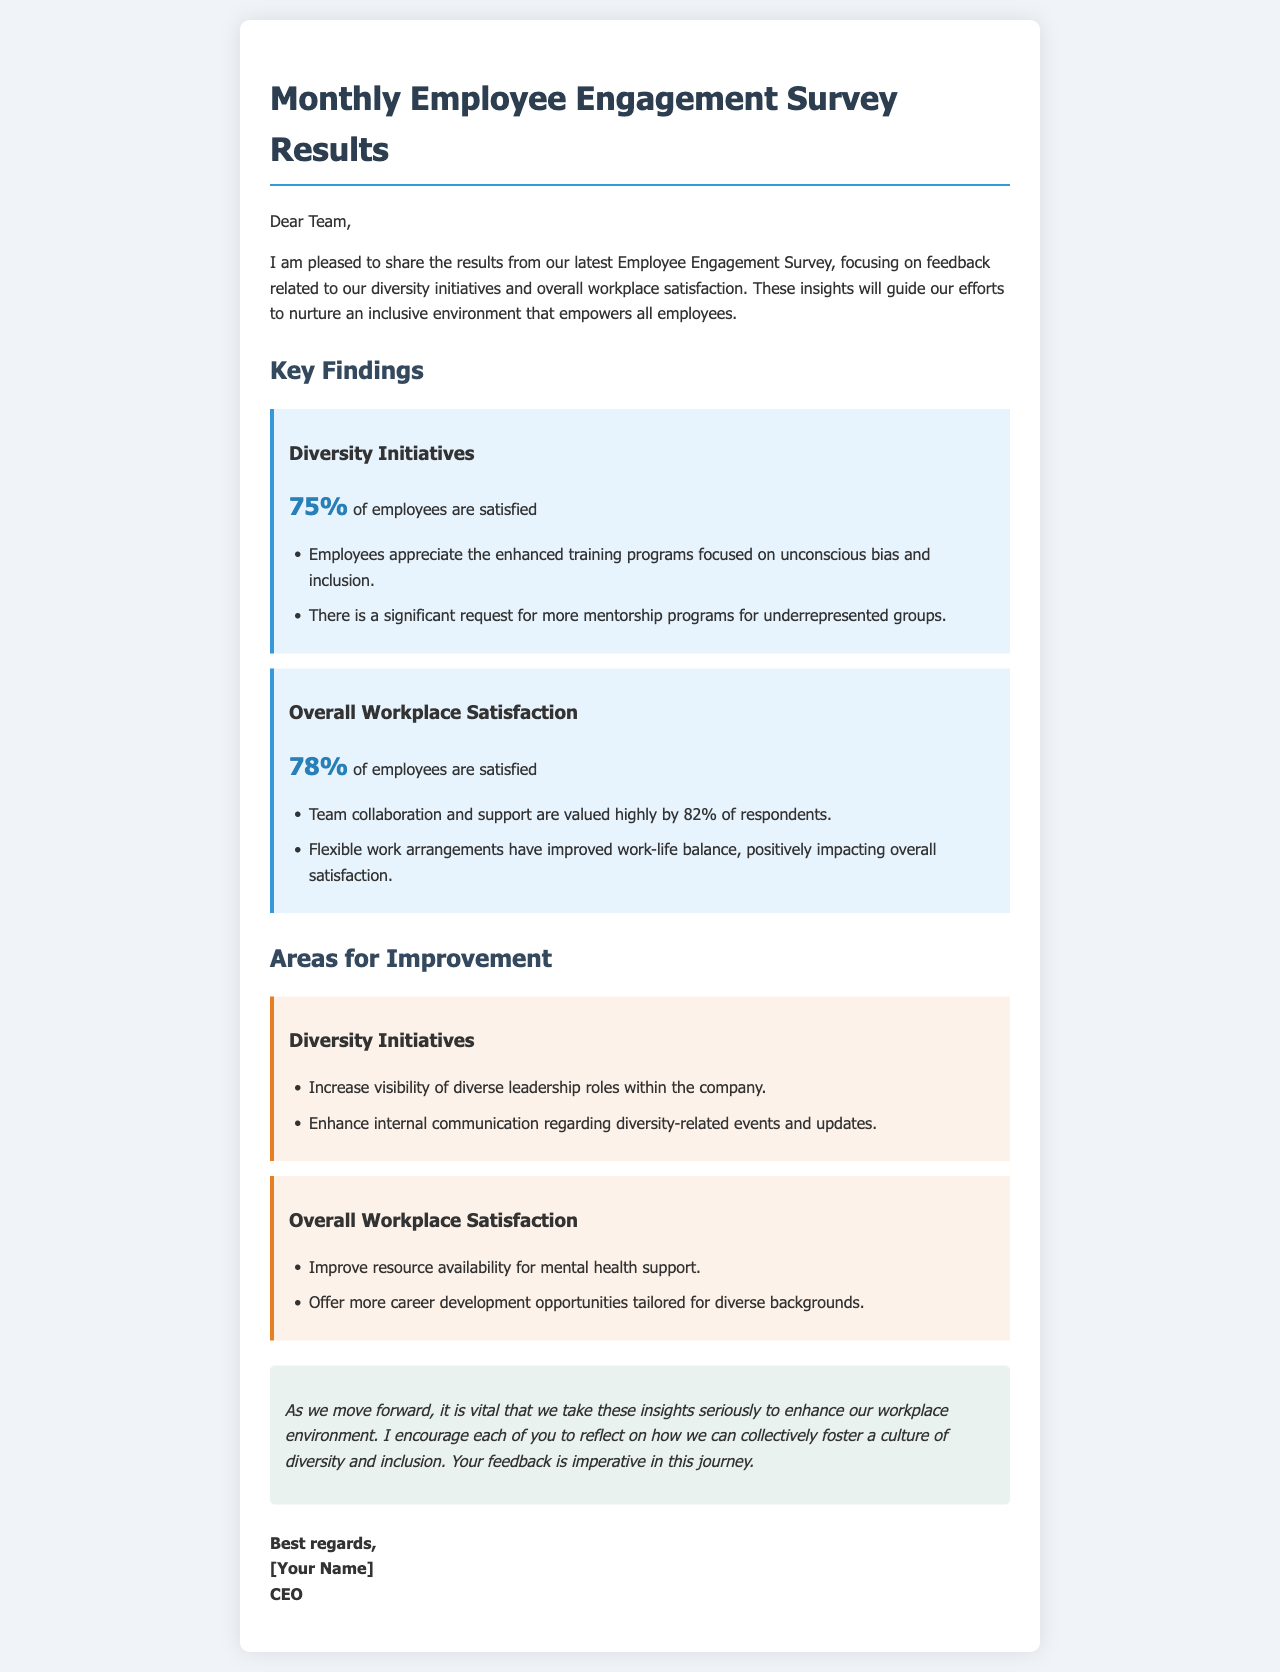What percentage of employees are satisfied with diversity initiatives? The document states that 75% of employees are satisfied with diversity initiatives.
Answer: 75% What key training program was appreciated by employees? Employees appreciated the enhanced training programs focused on unconscious bias and inclusion.
Answer: Unconscious bias and inclusion What is the overall satisfaction percentage of employees? The overall workplace satisfaction percentage reported in the document is 78%.
Answer: 78% Which area did employees want to improve regarding mental health support? The document explicitly mentions improving resource availability for mental health support as an area for improvement.
Answer: Resource availability What aspect of work arrangements positively impacted employee satisfaction? The document notes that flexible work arrangements have improved work-life balance.
Answer: Flexible work arrangements What percentage of respondents value team collaboration and support? The document states that 82% of respondents highly value team collaboration and support.
Answer: 82% What type of opportunities should be offered more for diverse backgrounds? The document mentions offering more career development opportunities tailored for diverse backgrounds.
Answer: Career development opportunities What is listed as a request for improving diversity initiatives? The document references a significant request for more mentorship programs for underrepresented groups.
Answer: Mentorship programs What is the purpose of sharing the survey results with the team? The purpose is to guide efforts towards nurturing an inclusive environment that empowers all employees, as stated in the introduction.
Answer: Nurture an inclusive environment 